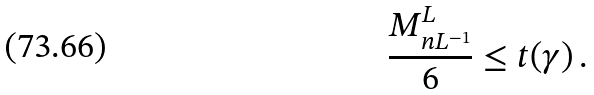<formula> <loc_0><loc_0><loc_500><loc_500>\frac { M ^ { L } _ { n L ^ { - 1 } } } { 6 } \leq t ( \gamma ) \, .</formula> 